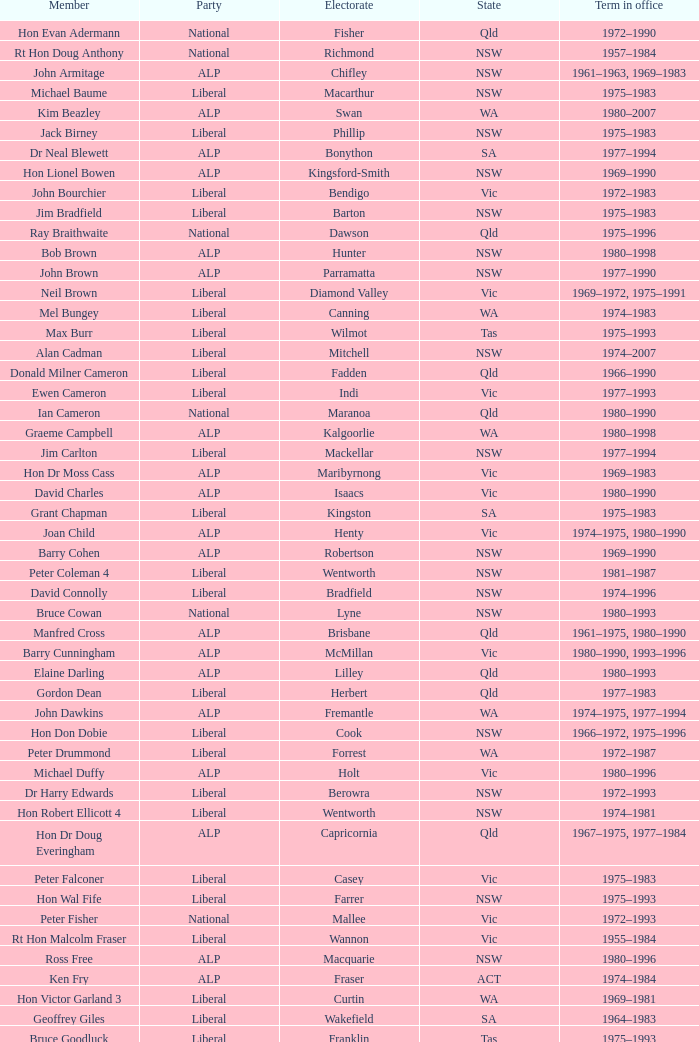When did hon les johnson serve in office? 1955–1966, 1969–1984. 